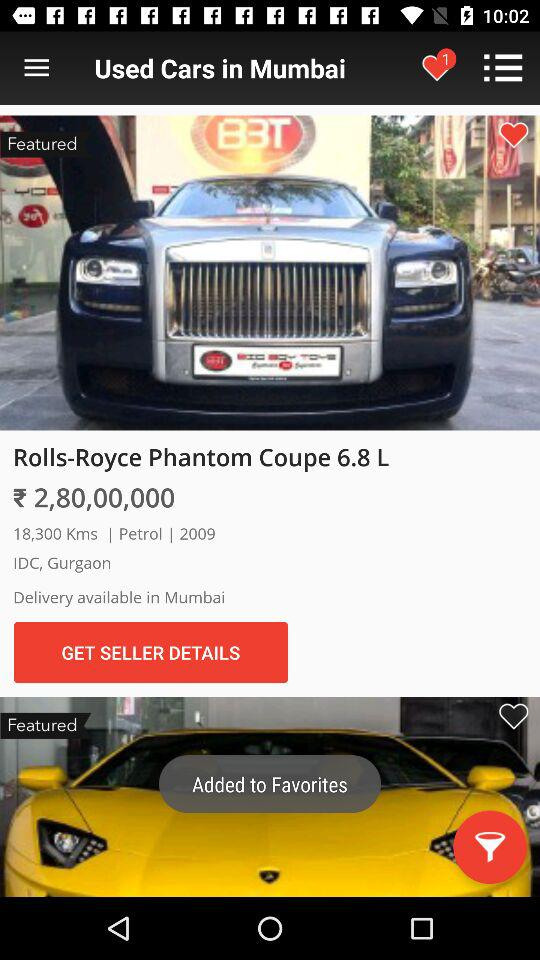What is the name of the car? The name of the car is Rolls-Royce Phantom Coupe 6.8 L. 